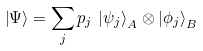<formula> <loc_0><loc_0><loc_500><loc_500>\left | \Psi \right \rangle = \sum _ { j } p _ { j } \, \left | \psi _ { j } \right \rangle _ { A } \otimes \left | \phi _ { j } \right \rangle _ { B }</formula> 